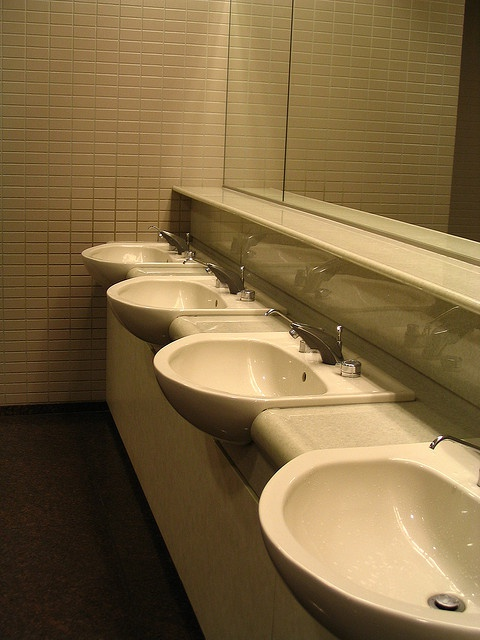Describe the objects in this image and their specific colors. I can see sink in gray and tan tones, sink in gray, tan, and black tones, sink in gray, tan, and olive tones, and sink in gray and tan tones in this image. 